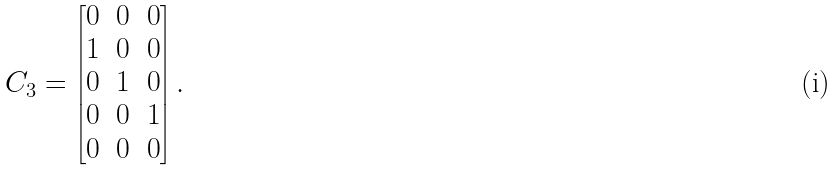<formula> <loc_0><loc_0><loc_500><loc_500>C _ { 3 } = \begin{bmatrix} 0 & 0 & 0 \\ 1 & 0 & 0 \\ 0 & 1 & 0 \\ 0 & 0 & 1 \\ 0 & 0 & 0 \end{bmatrix} .</formula> 